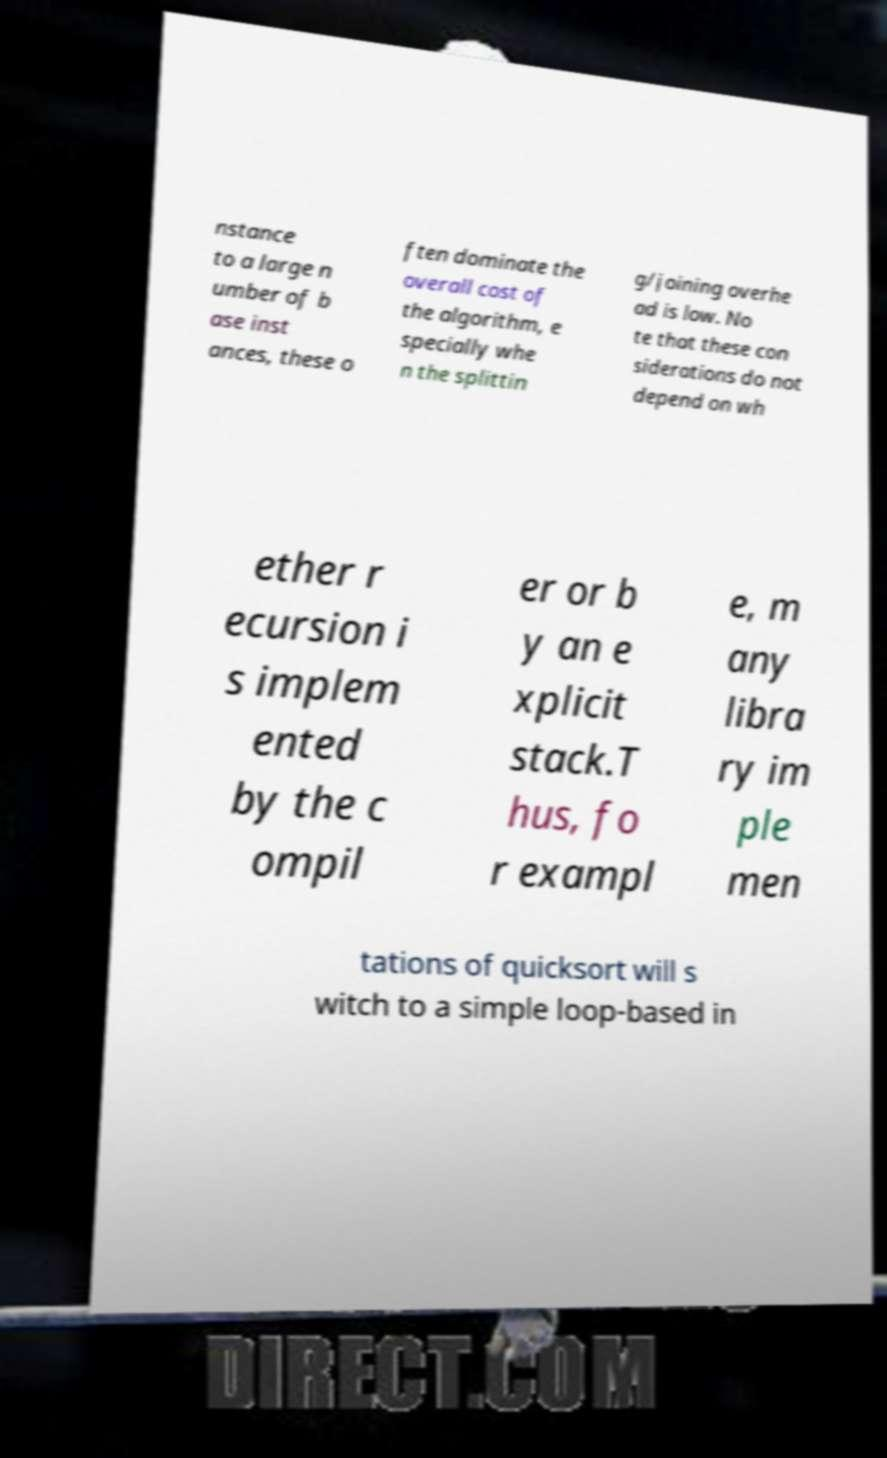I need the written content from this picture converted into text. Can you do that? nstance to a large n umber of b ase inst ances, these o ften dominate the overall cost of the algorithm, e specially whe n the splittin g/joining overhe ad is low. No te that these con siderations do not depend on wh ether r ecursion i s implem ented by the c ompil er or b y an e xplicit stack.T hus, fo r exampl e, m any libra ry im ple men tations of quicksort will s witch to a simple loop-based in 